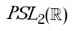Convert formula to latex. <formula><loc_0><loc_0><loc_500><loc_500>P S L _ { 2 } ( \mathbb { R } )</formula> 